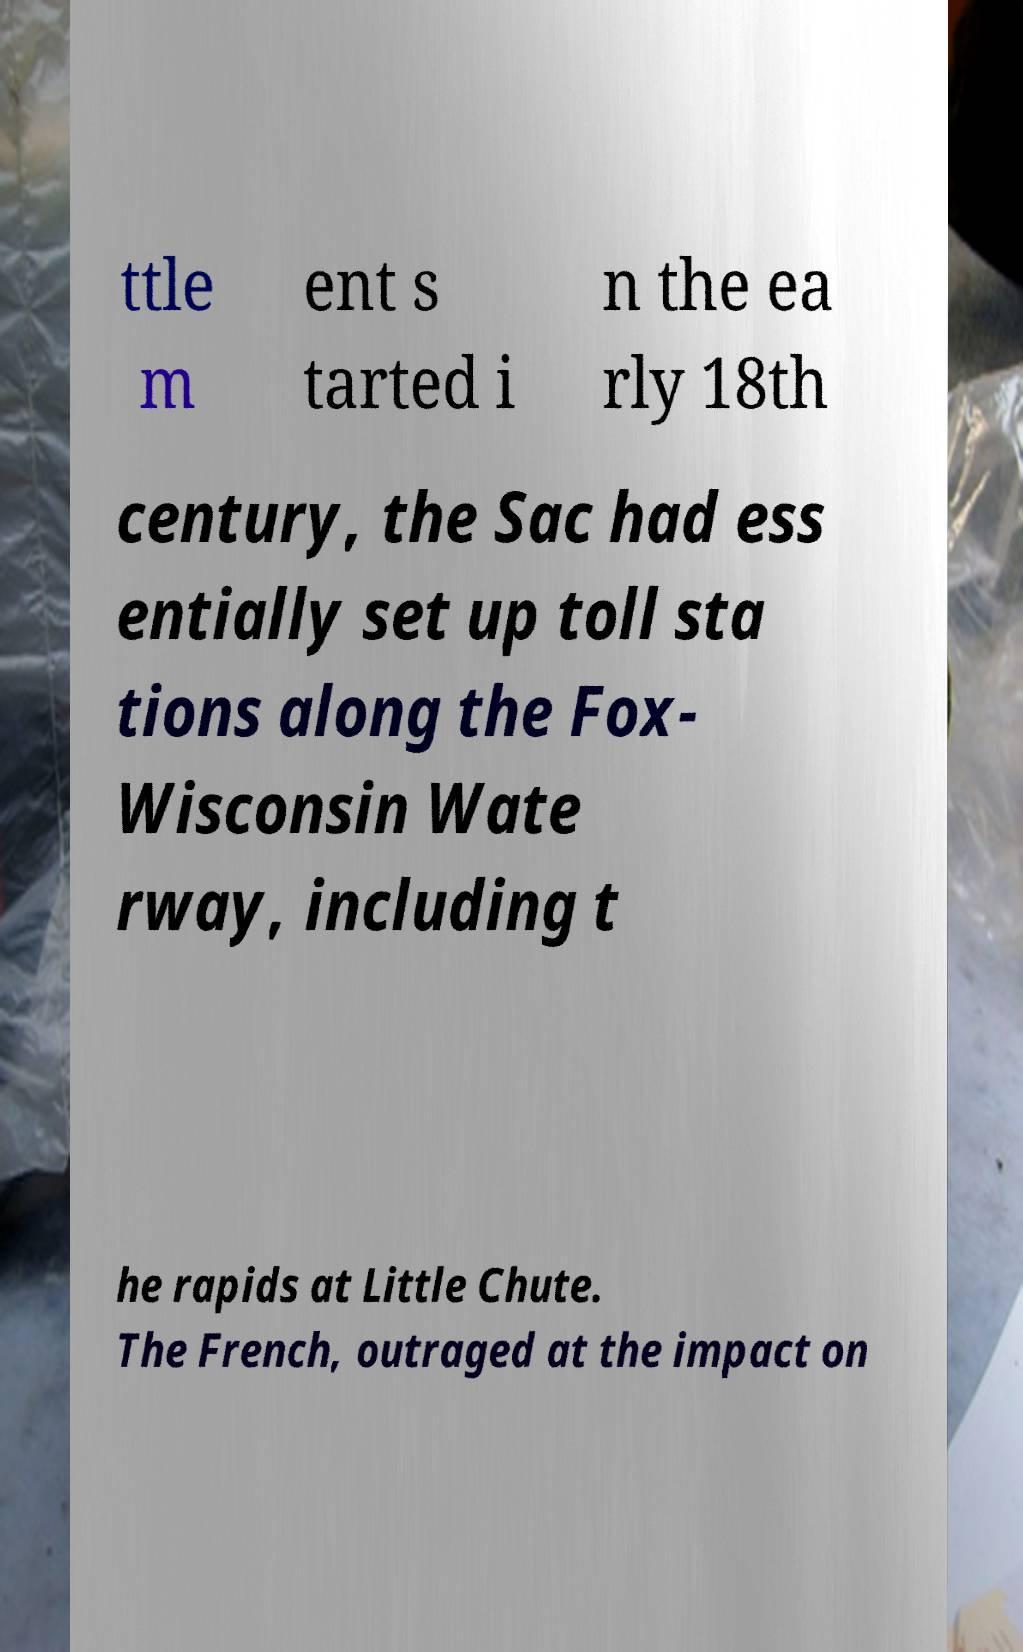What messages or text are displayed in this image? I need them in a readable, typed format. ttle m ent s tarted i n the ea rly 18th century, the Sac had ess entially set up toll sta tions along the Fox- Wisconsin Wate rway, including t he rapids at Little Chute. The French, outraged at the impact on 